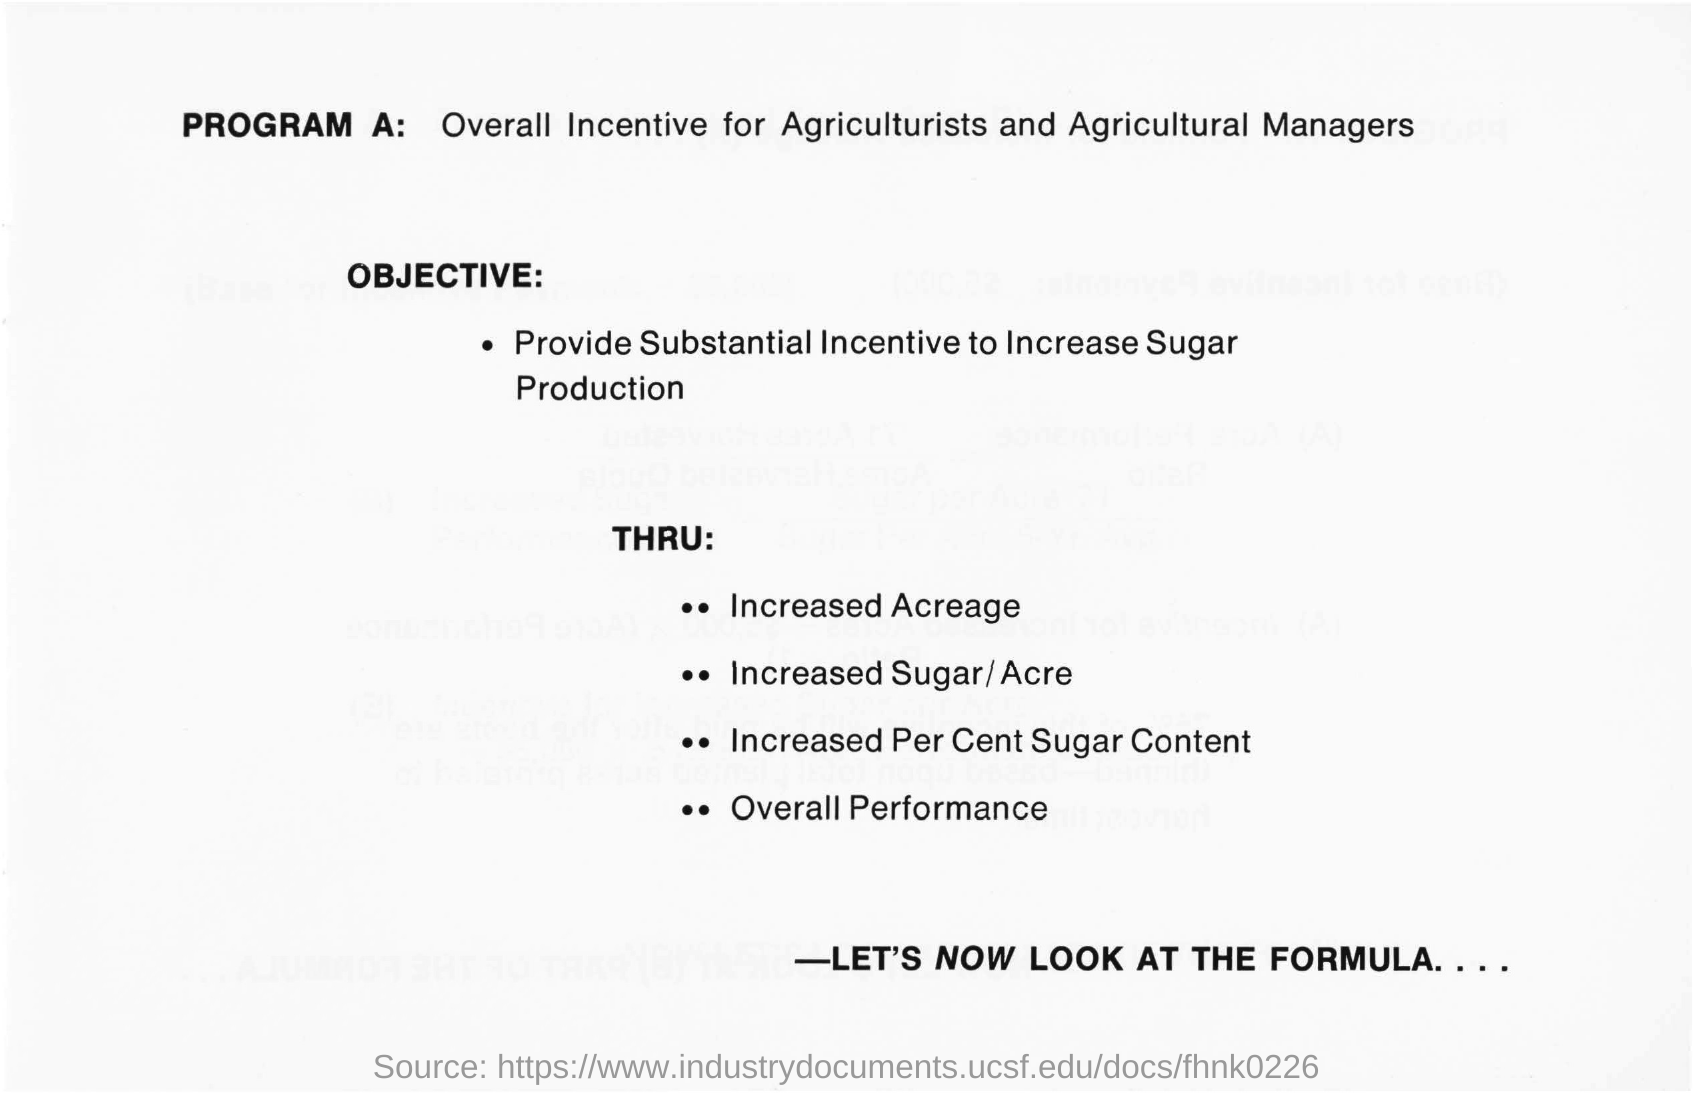Highlight a few significant elements in this photo. The objective is to provide substantial incentives to increase sugar production. Program A is a comprehensive initiative that offers a universal incentive for agriculturists and agricultural managers to achieve their goals and improve their performance in the field. 